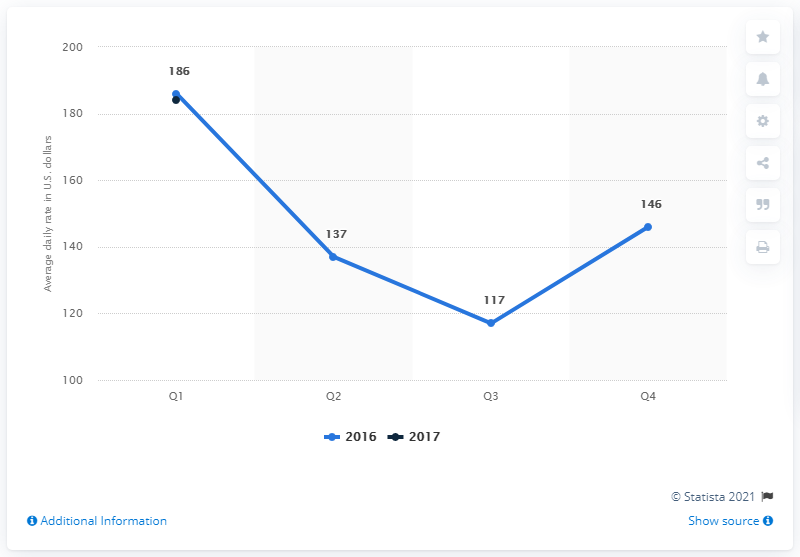Draw attention to some important aspects in this diagram. According to data from the first quarter of 2017, the average daily rate of hotels in Phoenix, Arizona, in the United States was 184 U.S. dollars. 